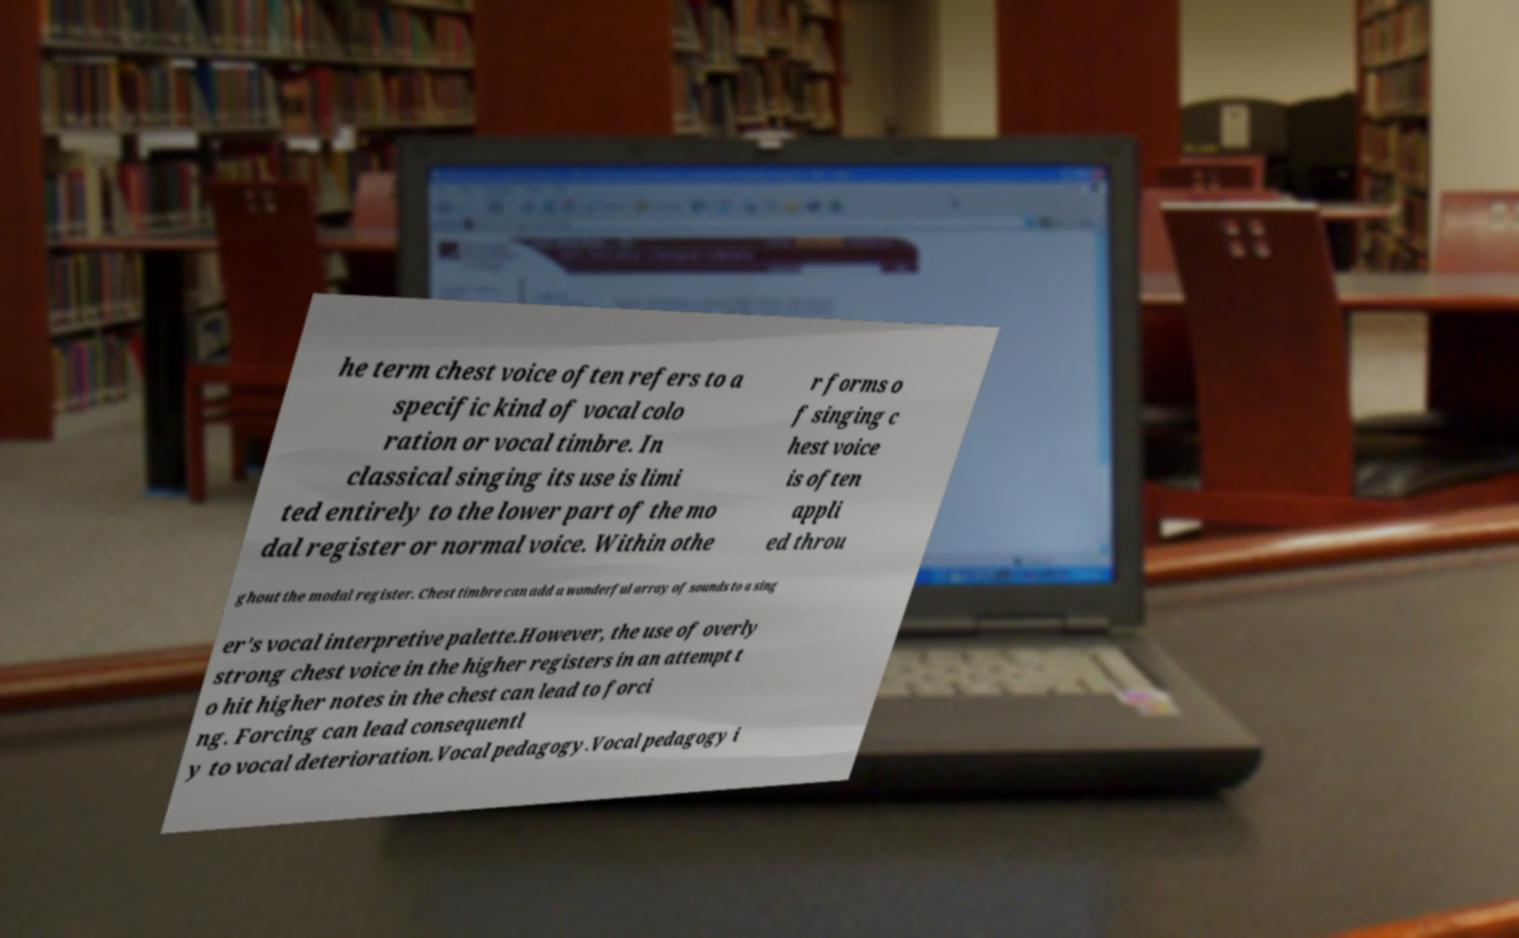Please identify and transcribe the text found in this image. he term chest voice often refers to a specific kind of vocal colo ration or vocal timbre. In classical singing its use is limi ted entirely to the lower part of the mo dal register or normal voice. Within othe r forms o f singing c hest voice is often appli ed throu ghout the modal register. Chest timbre can add a wonderful array of sounds to a sing er's vocal interpretive palette.However, the use of overly strong chest voice in the higher registers in an attempt t o hit higher notes in the chest can lead to forci ng. Forcing can lead consequentl y to vocal deterioration.Vocal pedagogy.Vocal pedagogy i 